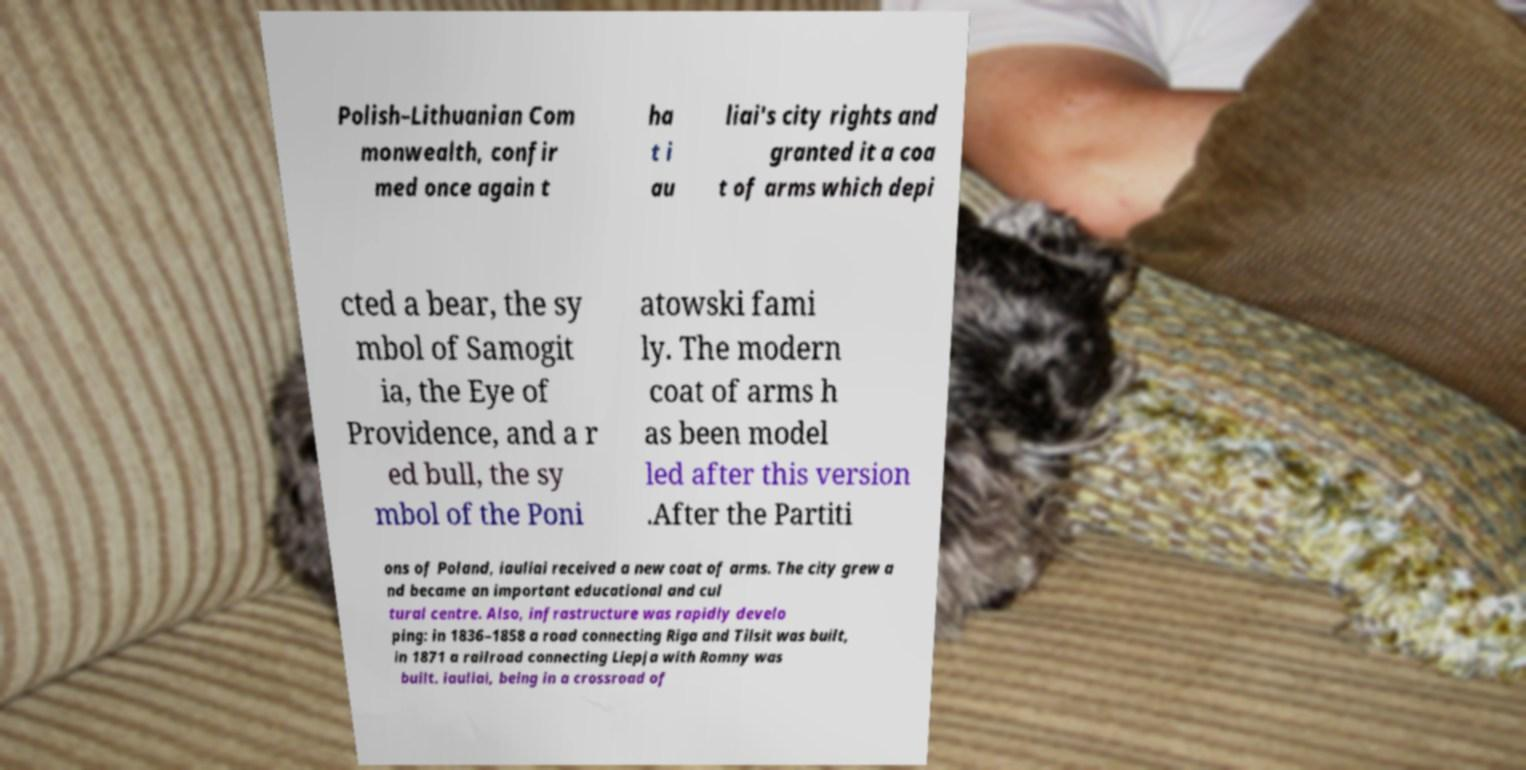Please read and relay the text visible in this image. What does it say? Polish–Lithuanian Com monwealth, confir med once again t ha t i au liai's city rights and granted it a coa t of arms which depi cted a bear, the sy mbol of Samogit ia, the Eye of Providence, and a r ed bull, the sy mbol of the Poni atowski fami ly. The modern coat of arms h as been model led after this version .After the Partiti ons of Poland, iauliai received a new coat of arms. The city grew a nd became an important educational and cul tural centre. Also, infrastructure was rapidly develo ping: in 1836–1858 a road connecting Riga and Tilsit was built, in 1871 a railroad connecting Liepja with Romny was built. iauliai, being in a crossroad of 